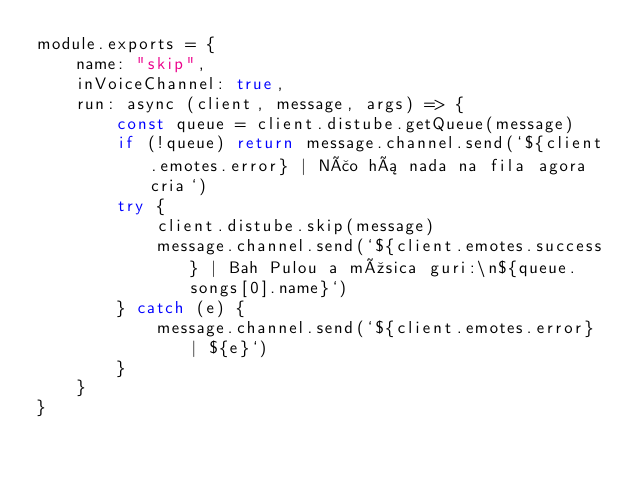<code> <loc_0><loc_0><loc_500><loc_500><_JavaScript_>module.exports = {
    name: "skip",
    inVoiceChannel: true,
    run: async (client, message, args) => {
        const queue = client.distube.getQueue(message)
        if (!queue) return message.channel.send(`${client.emotes.error} | Não há nada na fila agora cria`)
        try {
            client.distube.skip(message)
            message.channel.send(`${client.emotes.success} | Bah Pulou a música guri:\n${queue.songs[0].name}`)
        } catch (e) {
            message.channel.send(`${client.emotes.error} | ${e}`)
        }
    }
}
</code> 